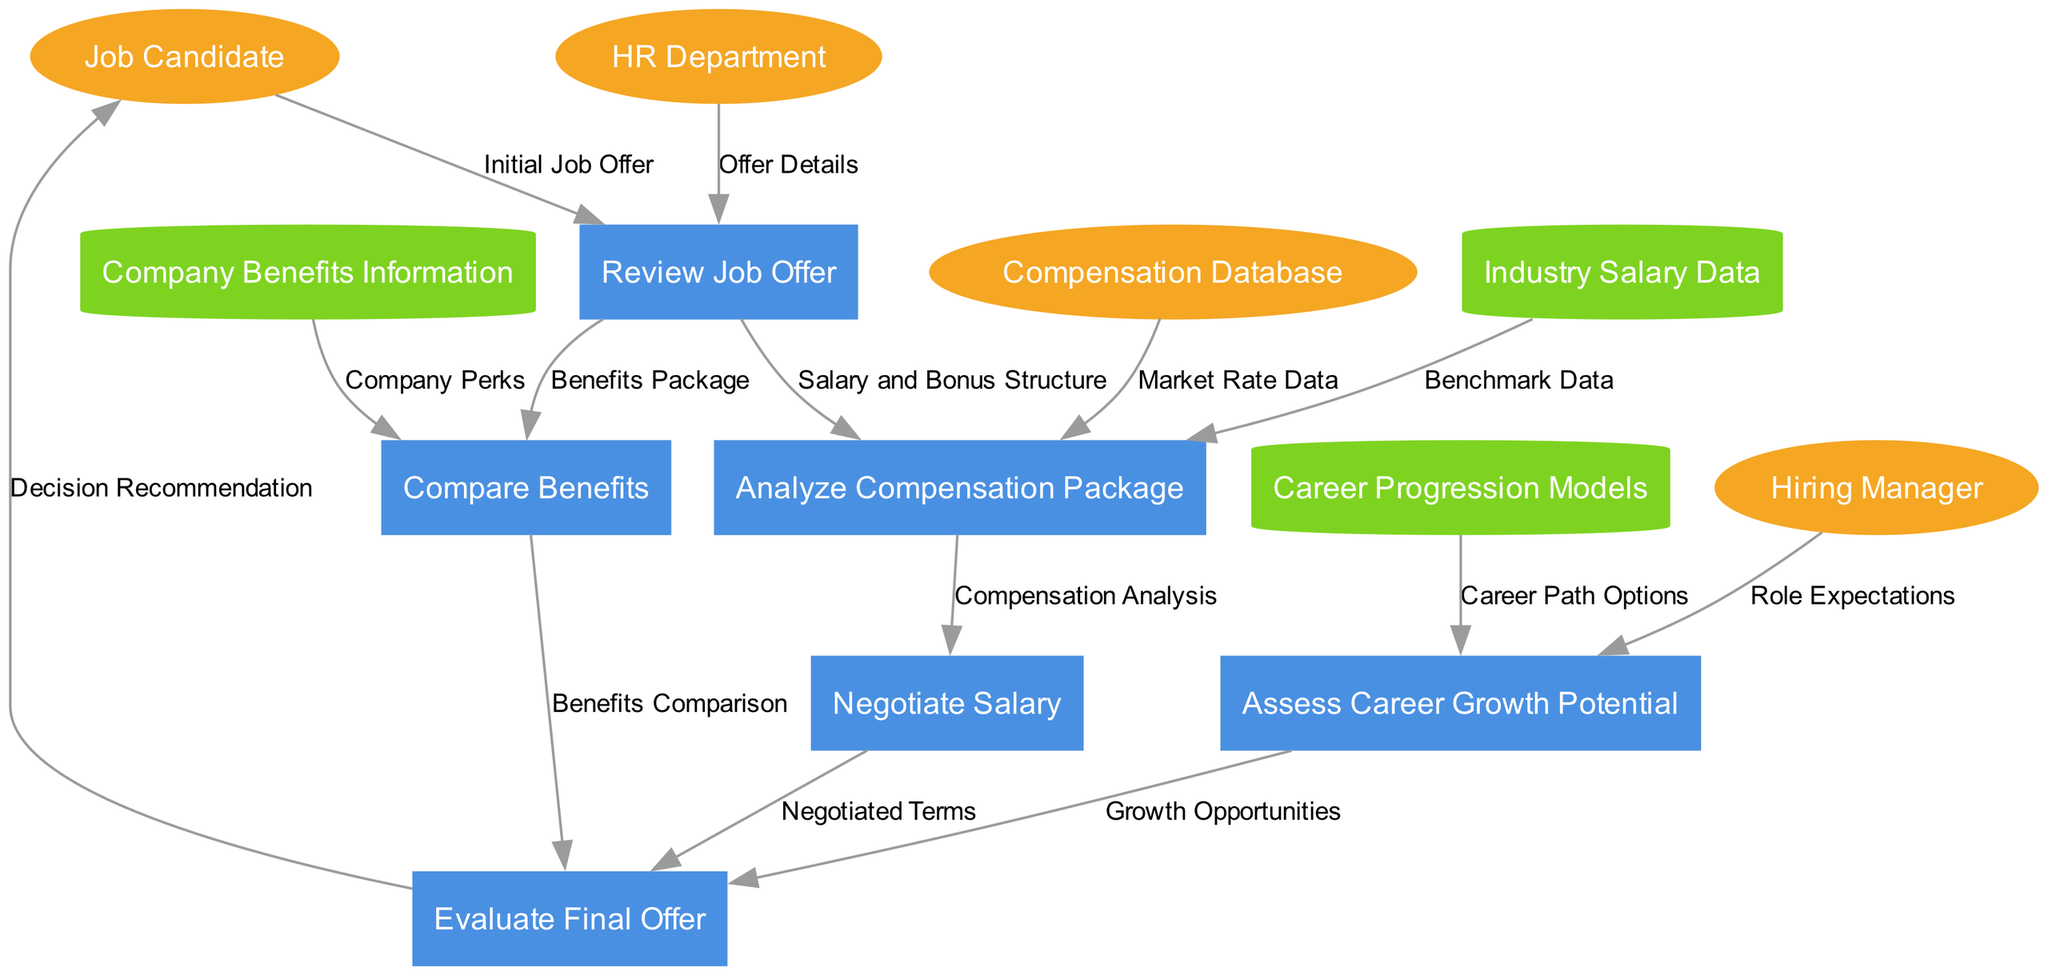What is the last process in the job offer evaluation? The last process in the diagram is "Evaluate Final Offer," which is where the job candidate, after going through all the assessments and negotiations, makes a decision about the job offer.
Answer: Evaluate Final Offer How many external entities are represented in the diagram? There are four external entities: Job Candidate, HR Department, Hiring Manager, and Compensation Database. Counting these entities gives a total of four.
Answer: Four Which data store provides information about salary benchmarks? The data store that provides salary benchmarks is "Industry Salary Data." This store contains contextual information on industry-specific compensation.
Answer: Industry Salary Data What is analyzed after the initial review of the job offer? After reviewing the job offer, the next step is "Analyze Compensation Package," which involves examining the salary and bonus structure presented in the offer.
Answer: Analyze Compensation Package How many data flows originate from the "Review Job Offer" process? Three data flows originate from the "Review Job Offer" process: to "Analyze Compensation Package," to "Compare Benefits," and to "Negotiate Salary." Thus, there are three data flows starting from that process.
Answer: Three Which process receives data from both "HR Department" and "Job Candidate"? The "Review Job Offer" process receives data from both the "HR Department" and the "Job Candidate," as it depends on information provided by both parties regarding the job offer details.
Answer: Review Job Offer Which flow indicates the information about company perks? The flow labeled "Company Perks" indicates the information about company benefits, feeding into the "Compare Benefits" process. This helps in making a comparative analysis of what the company offers.
Answer: Company Perks What is the first process in the evaluation sequence? The first process in the evaluation sequence is "Review Job Offer," where the initial job offer is analyzed based on inputs from the job candidate and HR department.
Answer: Review Job Offer Which process is dependent on data from the "Hiring Manager"? The process "Assess Career Growth Potential" is dependent on data from the "Hiring Manager," as it includes insights into the expectations and career trajectory associated with the role.
Answer: Assess Career Growth Potential 